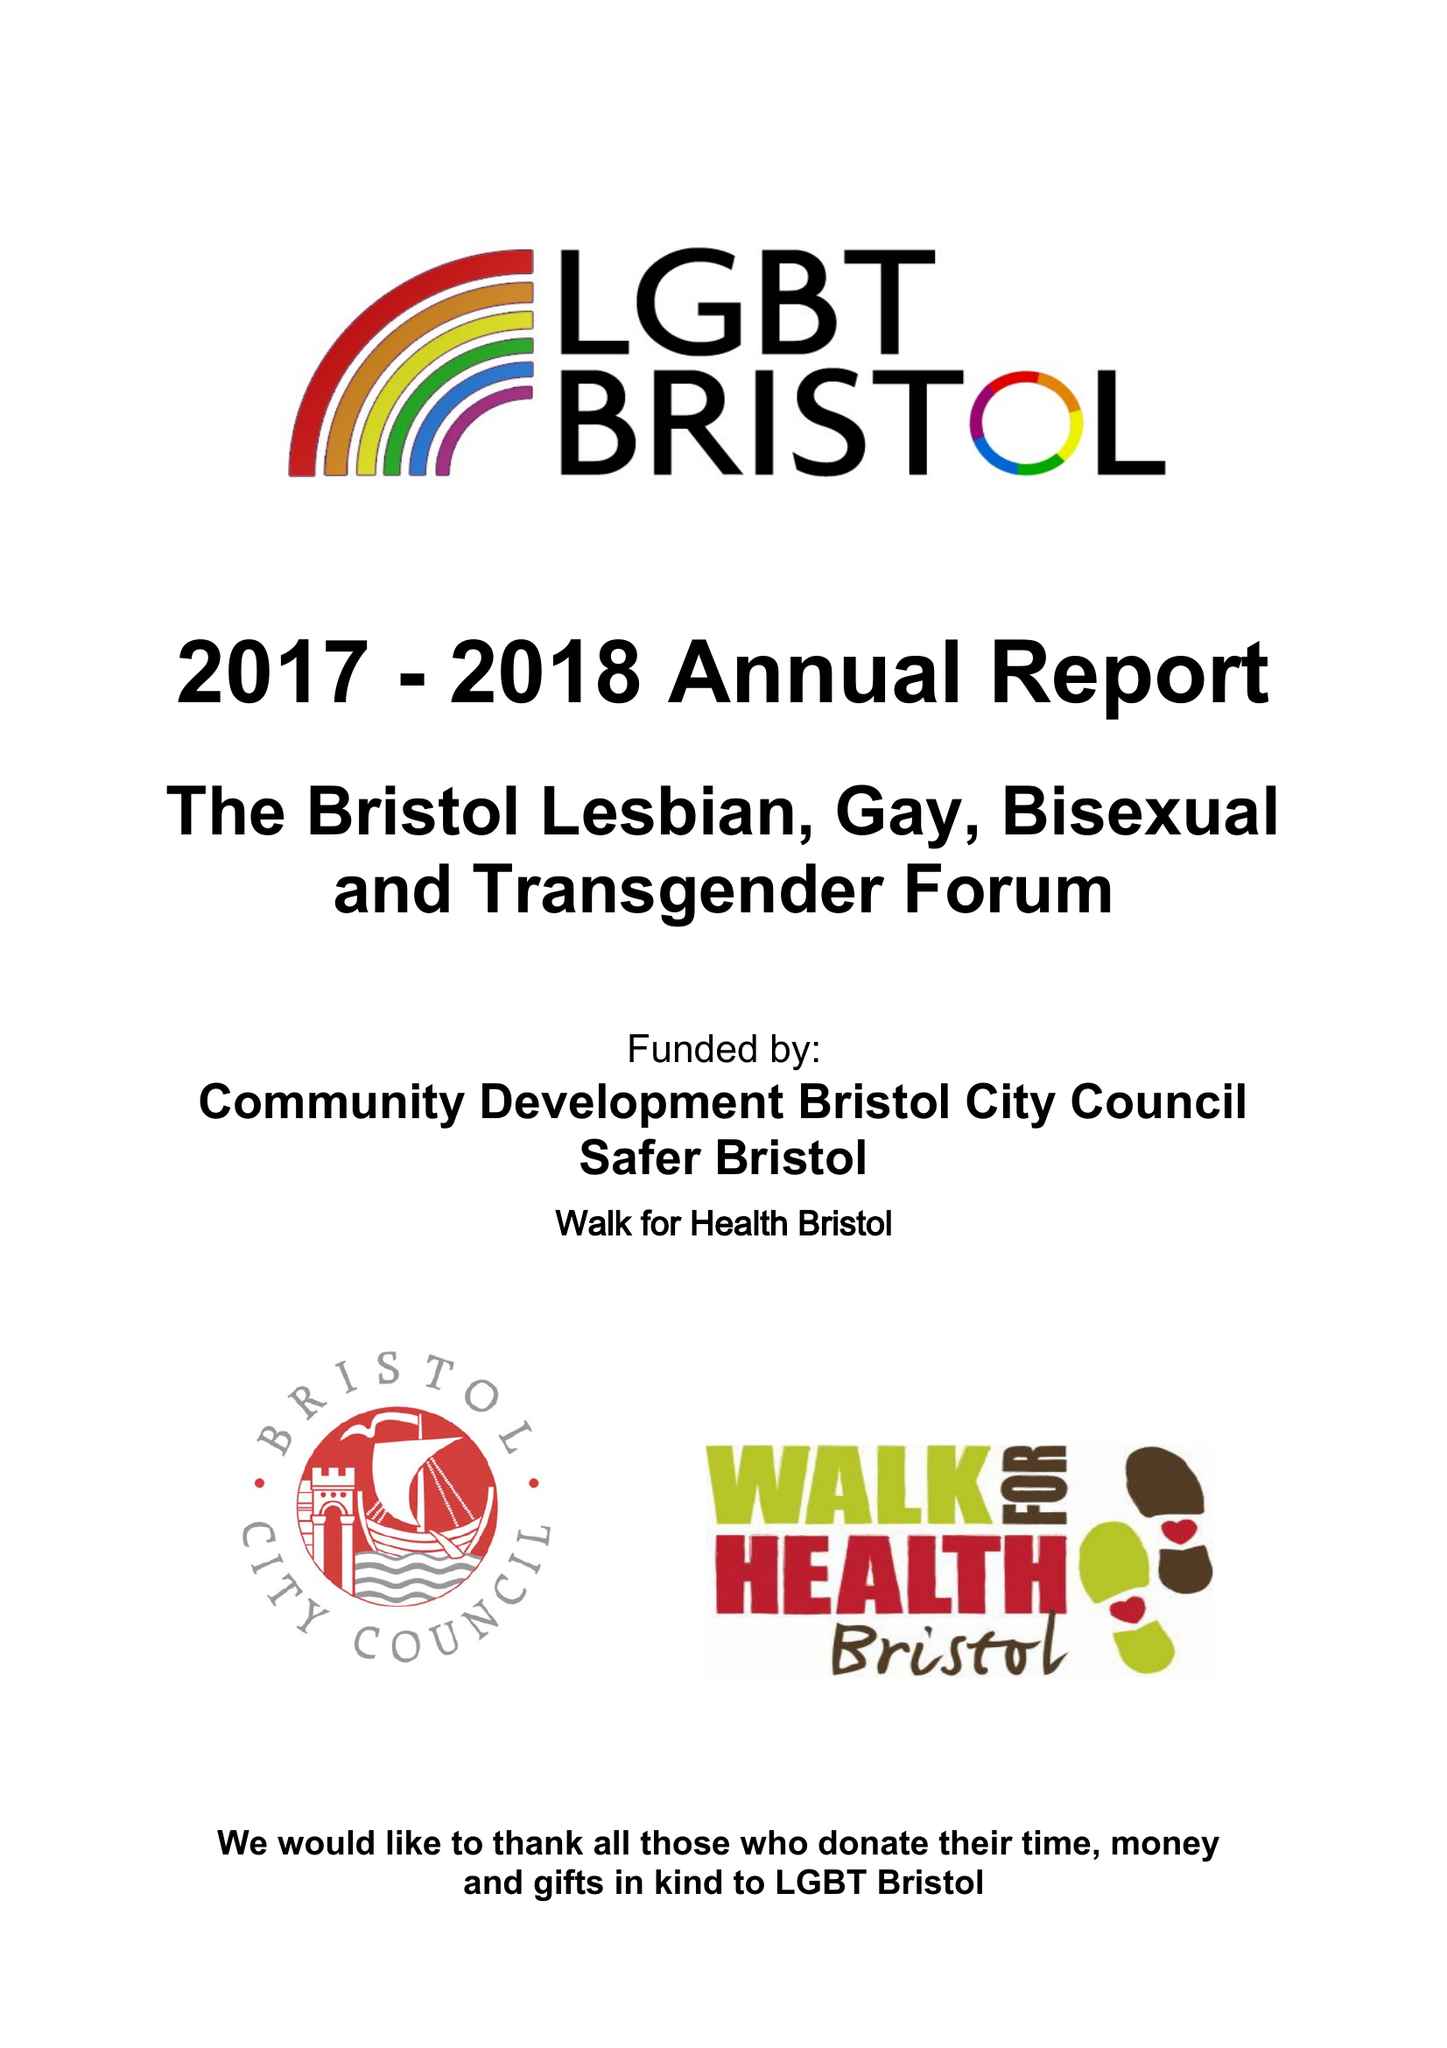What is the value for the address__post_town?
Answer the question using a single word or phrase. BRISTOL 